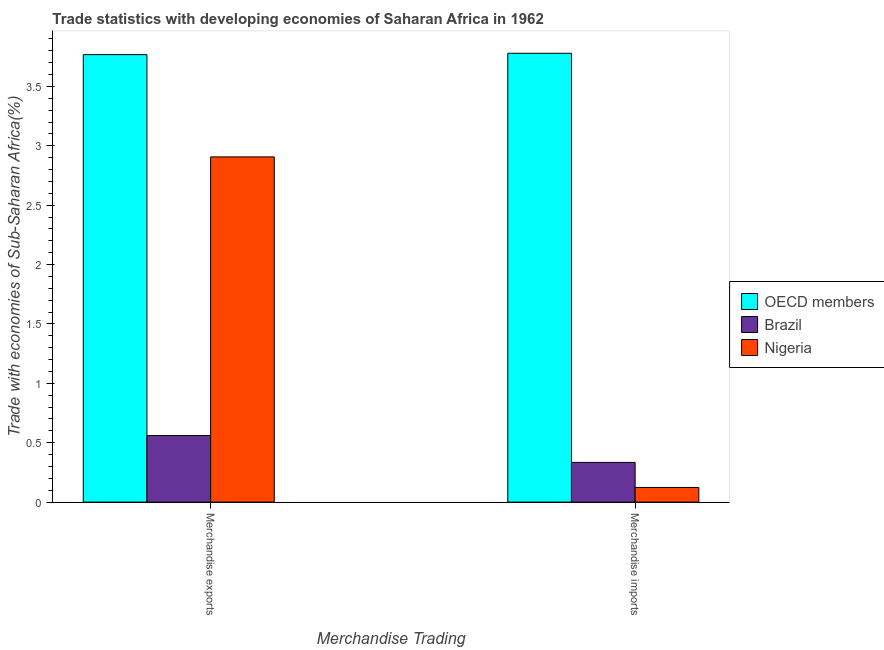How many groups of bars are there?
Your answer should be compact. 2. Are the number of bars on each tick of the X-axis equal?
Provide a short and direct response. Yes. How many bars are there on the 2nd tick from the left?
Give a very brief answer. 3. How many bars are there on the 2nd tick from the right?
Your response must be concise. 3. What is the merchandise imports in Nigeria?
Offer a terse response. 0.12. Across all countries, what is the maximum merchandise imports?
Provide a succinct answer. 3.78. Across all countries, what is the minimum merchandise imports?
Offer a terse response. 0.12. In which country was the merchandise imports maximum?
Ensure brevity in your answer.  OECD members. In which country was the merchandise imports minimum?
Offer a very short reply. Nigeria. What is the total merchandise imports in the graph?
Make the answer very short. 4.24. What is the difference between the merchandise imports in Brazil and that in OECD members?
Your answer should be compact. -3.44. What is the difference between the merchandise exports in Nigeria and the merchandise imports in Brazil?
Your answer should be compact. 2.57. What is the average merchandise imports per country?
Your answer should be very brief. 1.41. What is the difference between the merchandise imports and merchandise exports in Brazil?
Offer a very short reply. -0.23. What is the ratio of the merchandise imports in Brazil to that in OECD members?
Give a very brief answer. 0.09. In how many countries, is the merchandise exports greater than the average merchandise exports taken over all countries?
Your answer should be very brief. 2. What does the 1st bar from the left in Merchandise imports represents?
Your response must be concise. OECD members. What does the 1st bar from the right in Merchandise imports represents?
Offer a very short reply. Nigeria. How many bars are there?
Give a very brief answer. 6. Are all the bars in the graph horizontal?
Keep it short and to the point. No. Are the values on the major ticks of Y-axis written in scientific E-notation?
Offer a terse response. No. Where does the legend appear in the graph?
Offer a very short reply. Center right. How many legend labels are there?
Your answer should be very brief. 3. What is the title of the graph?
Your answer should be very brief. Trade statistics with developing economies of Saharan Africa in 1962. Does "Panama" appear as one of the legend labels in the graph?
Your answer should be compact. No. What is the label or title of the X-axis?
Offer a very short reply. Merchandise Trading. What is the label or title of the Y-axis?
Provide a succinct answer. Trade with economies of Sub-Saharan Africa(%). What is the Trade with economies of Sub-Saharan Africa(%) of OECD members in Merchandise exports?
Give a very brief answer. 3.77. What is the Trade with economies of Sub-Saharan Africa(%) of Brazil in Merchandise exports?
Offer a very short reply. 0.56. What is the Trade with economies of Sub-Saharan Africa(%) of Nigeria in Merchandise exports?
Provide a short and direct response. 2.91. What is the Trade with economies of Sub-Saharan Africa(%) in OECD members in Merchandise imports?
Your answer should be very brief. 3.78. What is the Trade with economies of Sub-Saharan Africa(%) in Brazil in Merchandise imports?
Your response must be concise. 0.33. What is the Trade with economies of Sub-Saharan Africa(%) of Nigeria in Merchandise imports?
Make the answer very short. 0.12. Across all Merchandise Trading, what is the maximum Trade with economies of Sub-Saharan Africa(%) of OECD members?
Make the answer very short. 3.78. Across all Merchandise Trading, what is the maximum Trade with economies of Sub-Saharan Africa(%) in Brazil?
Keep it short and to the point. 0.56. Across all Merchandise Trading, what is the maximum Trade with economies of Sub-Saharan Africa(%) in Nigeria?
Offer a very short reply. 2.91. Across all Merchandise Trading, what is the minimum Trade with economies of Sub-Saharan Africa(%) of OECD members?
Your answer should be very brief. 3.77. Across all Merchandise Trading, what is the minimum Trade with economies of Sub-Saharan Africa(%) in Brazil?
Ensure brevity in your answer.  0.33. Across all Merchandise Trading, what is the minimum Trade with economies of Sub-Saharan Africa(%) in Nigeria?
Give a very brief answer. 0.12. What is the total Trade with economies of Sub-Saharan Africa(%) in OECD members in the graph?
Give a very brief answer. 7.55. What is the total Trade with economies of Sub-Saharan Africa(%) of Brazil in the graph?
Your response must be concise. 0.9. What is the total Trade with economies of Sub-Saharan Africa(%) of Nigeria in the graph?
Make the answer very short. 3.03. What is the difference between the Trade with economies of Sub-Saharan Africa(%) in OECD members in Merchandise exports and that in Merchandise imports?
Give a very brief answer. -0.01. What is the difference between the Trade with economies of Sub-Saharan Africa(%) of Brazil in Merchandise exports and that in Merchandise imports?
Ensure brevity in your answer.  0.23. What is the difference between the Trade with economies of Sub-Saharan Africa(%) of Nigeria in Merchandise exports and that in Merchandise imports?
Provide a succinct answer. 2.78. What is the difference between the Trade with economies of Sub-Saharan Africa(%) of OECD members in Merchandise exports and the Trade with economies of Sub-Saharan Africa(%) of Brazil in Merchandise imports?
Your answer should be very brief. 3.43. What is the difference between the Trade with economies of Sub-Saharan Africa(%) in OECD members in Merchandise exports and the Trade with economies of Sub-Saharan Africa(%) in Nigeria in Merchandise imports?
Offer a very short reply. 3.64. What is the difference between the Trade with economies of Sub-Saharan Africa(%) of Brazil in Merchandise exports and the Trade with economies of Sub-Saharan Africa(%) of Nigeria in Merchandise imports?
Offer a very short reply. 0.44. What is the average Trade with economies of Sub-Saharan Africa(%) in OECD members per Merchandise Trading?
Your answer should be compact. 3.77. What is the average Trade with economies of Sub-Saharan Africa(%) in Brazil per Merchandise Trading?
Ensure brevity in your answer.  0.45. What is the average Trade with economies of Sub-Saharan Africa(%) of Nigeria per Merchandise Trading?
Offer a terse response. 1.52. What is the difference between the Trade with economies of Sub-Saharan Africa(%) of OECD members and Trade with economies of Sub-Saharan Africa(%) of Brazil in Merchandise exports?
Provide a succinct answer. 3.21. What is the difference between the Trade with economies of Sub-Saharan Africa(%) in OECD members and Trade with economies of Sub-Saharan Africa(%) in Nigeria in Merchandise exports?
Make the answer very short. 0.86. What is the difference between the Trade with economies of Sub-Saharan Africa(%) in Brazil and Trade with economies of Sub-Saharan Africa(%) in Nigeria in Merchandise exports?
Give a very brief answer. -2.35. What is the difference between the Trade with economies of Sub-Saharan Africa(%) in OECD members and Trade with economies of Sub-Saharan Africa(%) in Brazil in Merchandise imports?
Your answer should be compact. 3.44. What is the difference between the Trade with economies of Sub-Saharan Africa(%) of OECD members and Trade with economies of Sub-Saharan Africa(%) of Nigeria in Merchandise imports?
Provide a succinct answer. 3.66. What is the difference between the Trade with economies of Sub-Saharan Africa(%) in Brazil and Trade with economies of Sub-Saharan Africa(%) in Nigeria in Merchandise imports?
Offer a very short reply. 0.21. What is the ratio of the Trade with economies of Sub-Saharan Africa(%) in Brazil in Merchandise exports to that in Merchandise imports?
Ensure brevity in your answer.  1.67. What is the ratio of the Trade with economies of Sub-Saharan Africa(%) in Nigeria in Merchandise exports to that in Merchandise imports?
Keep it short and to the point. 23.56. What is the difference between the highest and the second highest Trade with economies of Sub-Saharan Africa(%) in OECD members?
Your answer should be very brief. 0.01. What is the difference between the highest and the second highest Trade with economies of Sub-Saharan Africa(%) in Brazil?
Give a very brief answer. 0.23. What is the difference between the highest and the second highest Trade with economies of Sub-Saharan Africa(%) of Nigeria?
Your answer should be very brief. 2.78. What is the difference between the highest and the lowest Trade with economies of Sub-Saharan Africa(%) of OECD members?
Provide a succinct answer. 0.01. What is the difference between the highest and the lowest Trade with economies of Sub-Saharan Africa(%) in Brazil?
Offer a very short reply. 0.23. What is the difference between the highest and the lowest Trade with economies of Sub-Saharan Africa(%) of Nigeria?
Your answer should be compact. 2.78. 